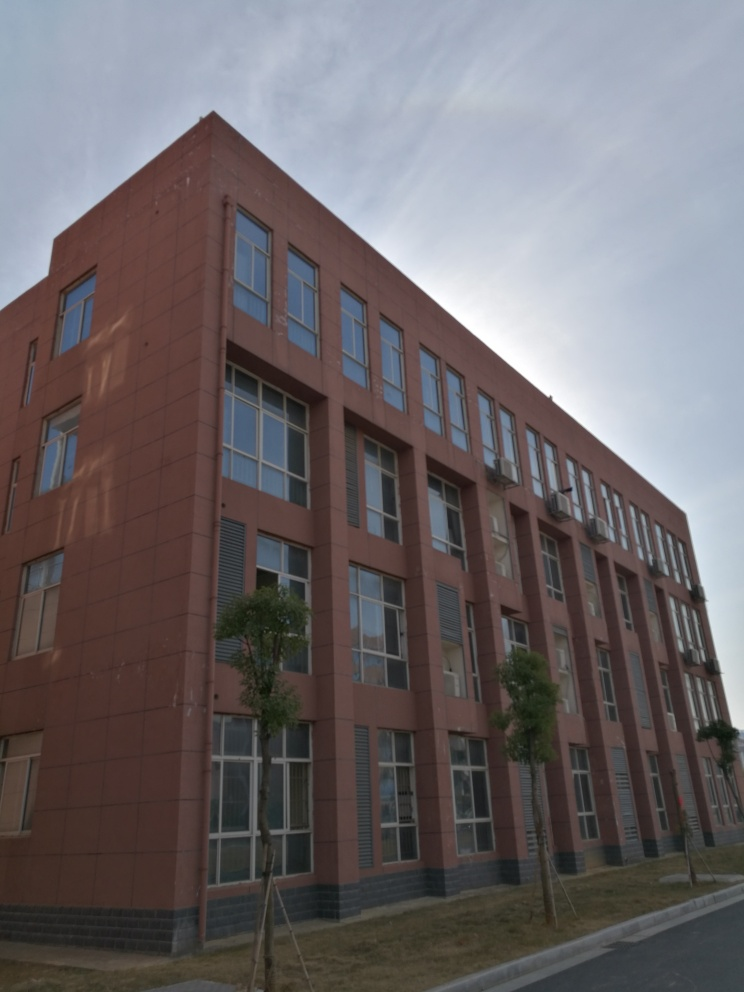Are there any quality issues with this image? The image appears to be slightly underexposed, leading to a loss of detail in darker areas, such as the lower parts of the building and the shadows. Additionally, there is a slight blur that might be due to the camera being out of focus or the subject moving, which reduces the overall sharpness of the image. Lastly, the photo seems to have some lens flare from the sunlight, which can be considered a quality issue depending on the photographic intent. 